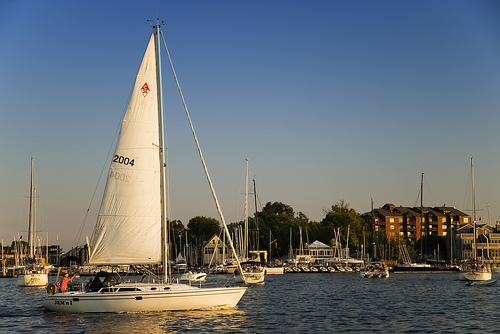Analyze the possible interactions among objects in the image. Boats are floating and docked near each other in the harbor, trees are near the water and shoreline, people are on the boats, and buildings are near the harbor. Count the number of sailboats in the picture. There are five sailboats in the image. What is the main transportation mode displayed in the image? Sailboats are the main transportation mode in this image. Count and briefly describe the trees in the scene. There are four different sets of leafy green trees with their positions and sizes described in the image information. In a few words, describe the general atmosphere of the scene. The scene is tranquil and pleasant, with boats in a harbor, trees, and clear sky. Classify the image sentiment: is it positive, negative, or neutral? The image sentiment can be classified as positive, as it depicts a serene harbor scene with sailboats and a clear blue sky. Briefly describe the colors and objects in the sky. The sky is clear blue with white clouds and a section where blue fades to white. Explain the different types of structures in the image. The structures in the image include multi-story buildings, apartment buildings, and a harbor with boats docked. Evaluate the image quality in terms of clarity and sharpness. The image has a high quality with clear objects, sharp lines, and well-defined positions and sizes. A lighthouse in the distance can be seen standing tall near the shoreline on the right side of the image. No, it's not mentioned in the image. 